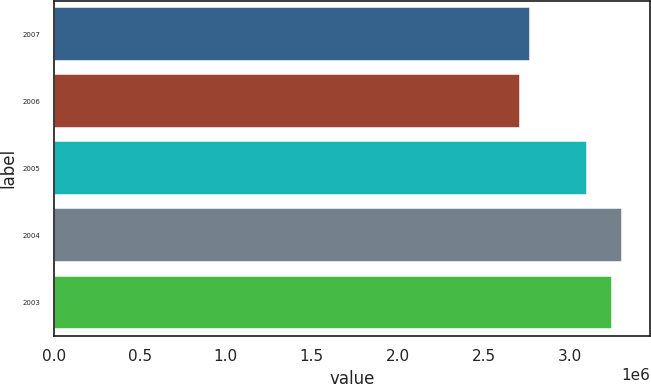Convert chart. <chart><loc_0><loc_0><loc_500><loc_500><bar_chart><fcel>2007<fcel>2006<fcel>2005<fcel>2004<fcel>2003<nl><fcel>2.7687e+06<fcel>2.714e+06<fcel>3.1e+06<fcel>3.3037e+06<fcel>3.249e+06<nl></chart> 